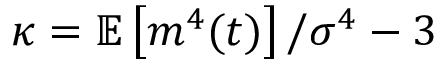Convert formula to latex. <formula><loc_0><loc_0><loc_500><loc_500>\kappa = \mathbb { E } \left [ m ^ { 4 } ( t ) \right ] / \sigma ^ { 4 } - 3</formula> 